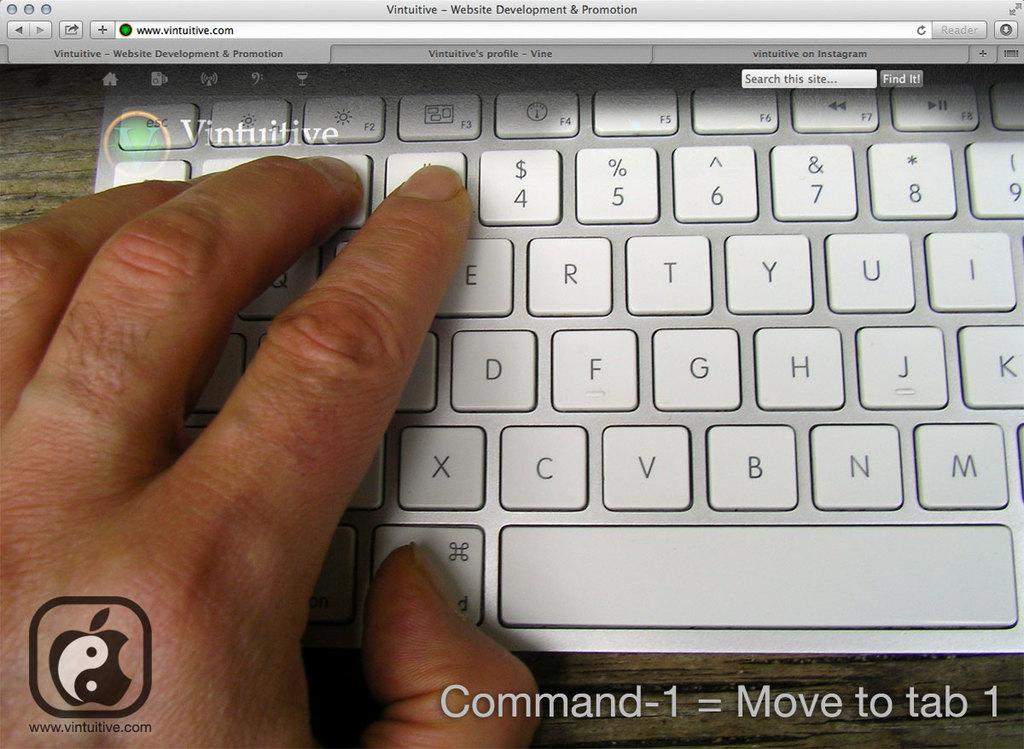What are we moving to?
Provide a short and direct response. Tab 1. What number is next to his finger?
Keep it short and to the point. 4. 